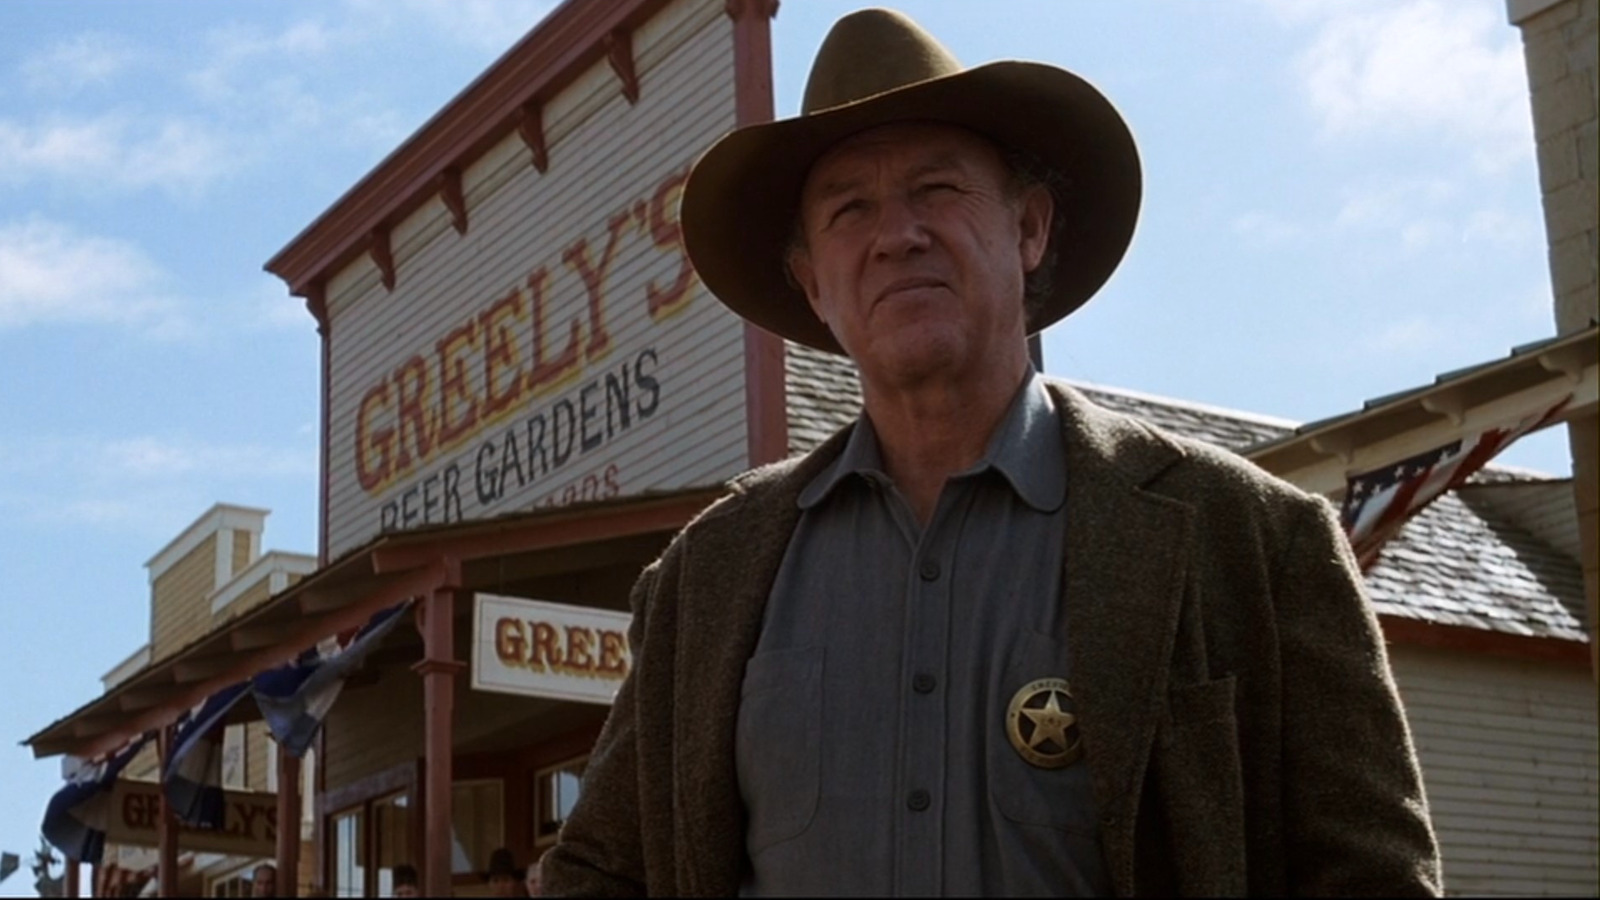Describe in detail the background setting of the image. In the background of the image, we see a building with a sign that reads 'Greeley's Beer Gardens.' The building has a rustic design typical of old-western architecture, with wooden beams and a sign that gives it a nostalgic feel. There are hints of other similar buildings in the vicinity, and the clear blue sky suggests a beautiful day in what appears to be a small, quiet town from the frontier times. 